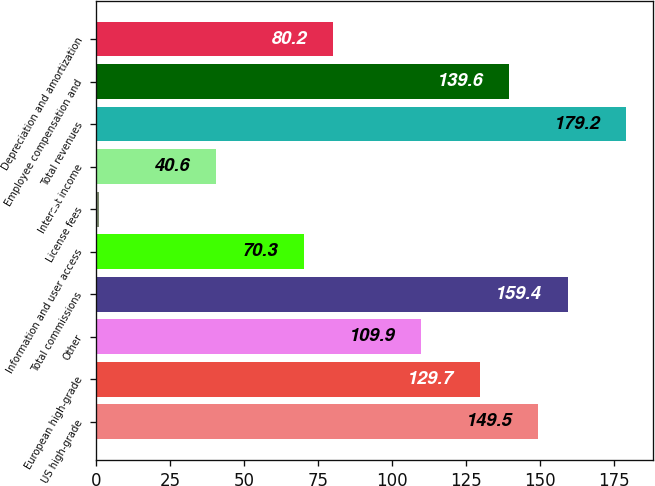Convert chart. <chart><loc_0><loc_0><loc_500><loc_500><bar_chart><fcel>US high-grade<fcel>European high-grade<fcel>Other<fcel>Total commissions<fcel>Information and user access<fcel>License fees<fcel>Interest income<fcel>Total revenues<fcel>Employee compensation and<fcel>Depreciation and amortization<nl><fcel>149.5<fcel>129.7<fcel>109.9<fcel>159.4<fcel>70.3<fcel>1<fcel>40.6<fcel>179.2<fcel>139.6<fcel>80.2<nl></chart> 